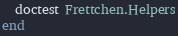Convert code to text. <code><loc_0><loc_0><loc_500><loc_500><_Elixir_>  doctest Frettchen.Helpers
end
</code> 